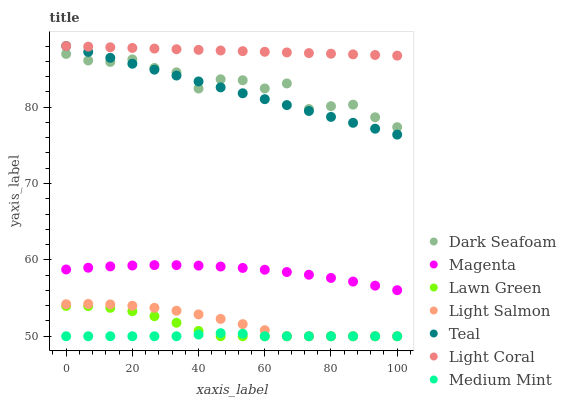Does Medium Mint have the minimum area under the curve?
Answer yes or no. Yes. Does Light Coral have the maximum area under the curve?
Answer yes or no. Yes. Does Lawn Green have the minimum area under the curve?
Answer yes or no. No. Does Lawn Green have the maximum area under the curve?
Answer yes or no. No. Is Teal the smoothest?
Answer yes or no. Yes. Is Dark Seafoam the roughest?
Answer yes or no. Yes. Is Lawn Green the smoothest?
Answer yes or no. No. Is Lawn Green the roughest?
Answer yes or no. No. Does Medium Mint have the lowest value?
Answer yes or no. Yes. Does Light Coral have the lowest value?
Answer yes or no. No. Does Teal have the highest value?
Answer yes or no. Yes. Does Lawn Green have the highest value?
Answer yes or no. No. Is Lawn Green less than Teal?
Answer yes or no. Yes. Is Teal greater than Magenta?
Answer yes or no. Yes. Does Medium Mint intersect Lawn Green?
Answer yes or no. Yes. Is Medium Mint less than Lawn Green?
Answer yes or no. No. Is Medium Mint greater than Lawn Green?
Answer yes or no. No. Does Lawn Green intersect Teal?
Answer yes or no. No. 